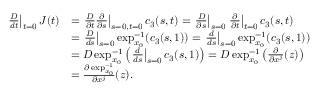<formula> <loc_0><loc_0><loc_500><loc_500>\begin{array} { r l } { \frac { D } { d t } \right | _ { t = 0 } J ( t ) } & { = \frac { D } { \partial t } \frac { \partial } { \partial s } \right | _ { s = 0 , t = 0 } c _ { 3 } ( s , t ) = \frac { D } { \partial s } \right | _ { s = 0 } \frac { \partial } { \partial t } \right | _ { t = 0 } c _ { 3 } ( s , t ) } \\ & { = \frac { D } { d s } \right | _ { s = 0 } \exp _ { x _ { 0 } } ^ { - 1 } ( c _ { 3 } ( s , 1 ) ) = \frac { d } { d s } \right | _ { s = 0 } \exp _ { x _ { 0 } } ^ { - 1 } ( c _ { 3 } ( s , 1 ) ) } \\ & { = D \exp _ { x _ { 0 } } ^ { - 1 } \left ( \frac { d } { d s } \right | _ { s = 0 } c _ { 3 } ( s , 1 ) \right ) = D \exp _ { x _ { 0 } } ^ { - 1 } \left ( \frac { \partial } { \partial x ^ { j } } ( z ) \right ) } \\ & { = \frac { \partial \exp _ { x _ { 0 } } ^ { - 1 } } { \partial x ^ { j } } ( z ) . } \end{array}</formula> 